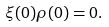Convert formula to latex. <formula><loc_0><loc_0><loc_500><loc_500>\xi ( 0 ) \rho ( 0 ) = 0 .</formula> 